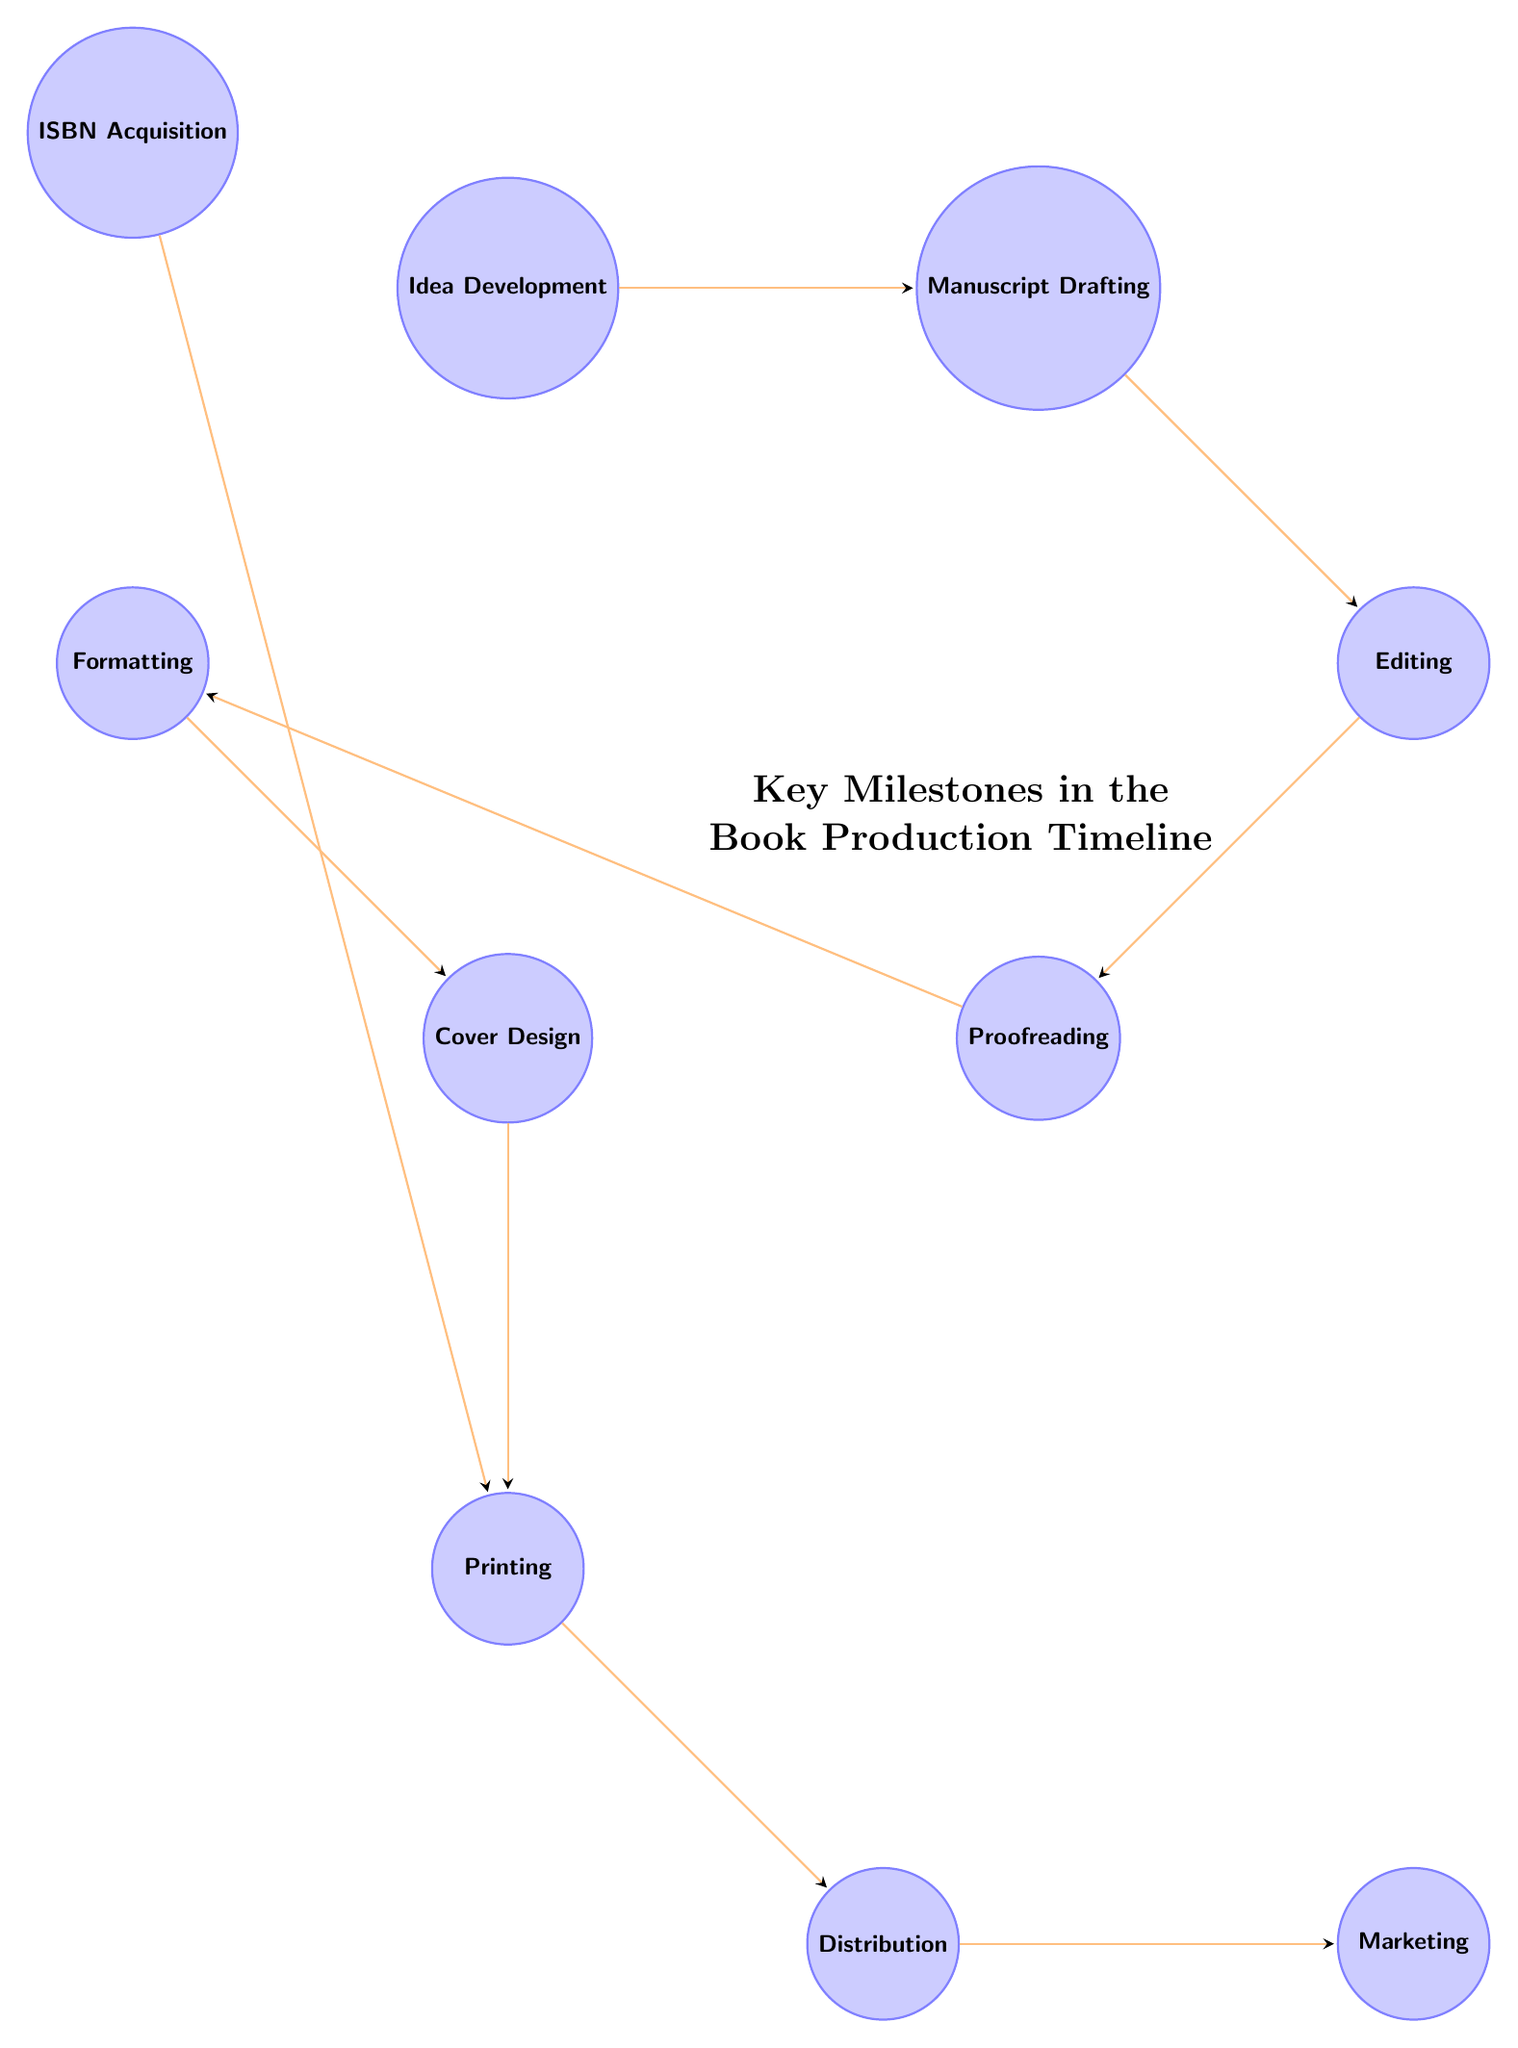What is the first milestone in the diagram? The first milestone visible in the diagram is "Idea Development," positioned at the far left, indicating it as the starting point of the book production process.
Answer: Idea Development How many nodes are there in total? By counting each of the individual steps or milestones represented in the diagram, there are a total of 10 distinct nodes.
Answer: 10 Which milestone comes after Editing? Following the "Editing" milestone in the diagram, the next node progressing in the timeline is "Proofreading."
Answer: Proofreading Is there a milestone that leads directly to both Printing and Marketing? In the diagram, the node "Printing" leads directly to both "Distribution" and subsequently, "Marketing," indicating its importance as a precursor to those activities.
Answer: Printing What is the relationship between Formatting and Cover Design? In the diagram, "Formatting" directly leads to "Cover Design," establishing a sequential relationship where formatting must precede the design of the cover.
Answer: Formatting → Cover Design Which two milestones are linked by an ISBN Acquisition? The "ISBN Acquisition" milestone is connected to the "Printing" milestone, indicating that an ISBN is necessary before printing can occur.
Answer: ISBN Acquisition and Printing What is the last milestone in the production timeline? The final milestone in the sequence is "Marketing," situated at the far right, indicating the last step to promote the book after all production phases are completed.
Answer: Marketing How many edges are present in the diagram? By observing the connections between nodes, there are a total of 9 edges that represent the directional flow from one milestone to another throughout the production process.
Answer: 9 Which milestone directly precedes Distribution? The milestone occurring immediately before "Distribution" in the diagram is "Printing," indicating that printing must be completed before distribution takes place.
Answer: Printing 